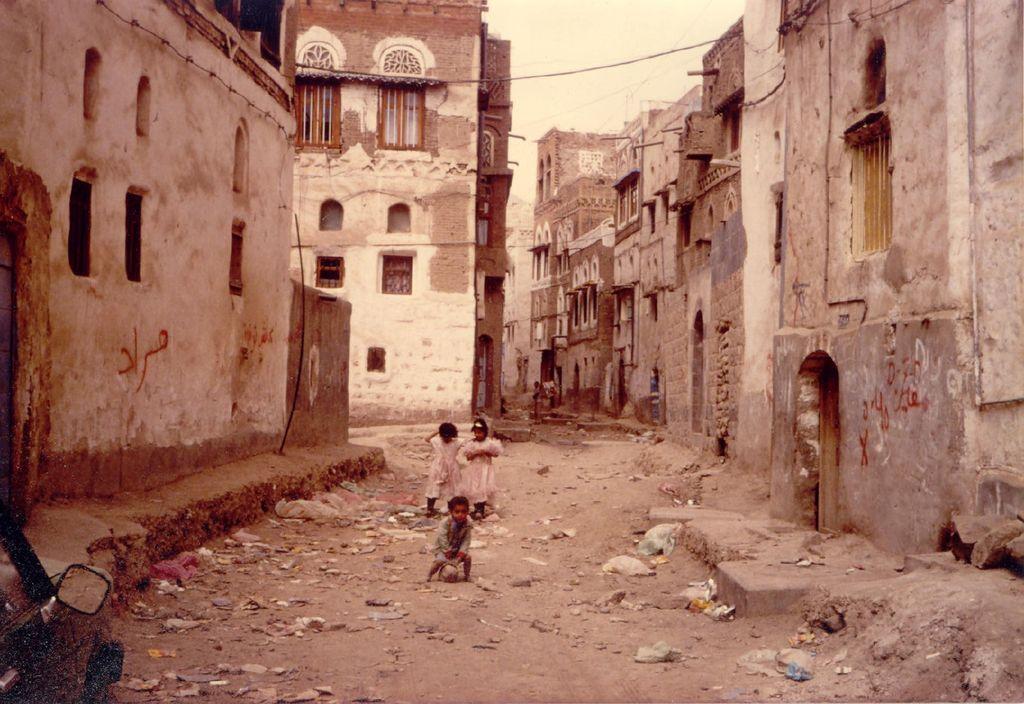Can you describe this image briefly? There are three children standing. These are the buildings with windows and doors. I can see the polythene bags, papers and few other things on the road 